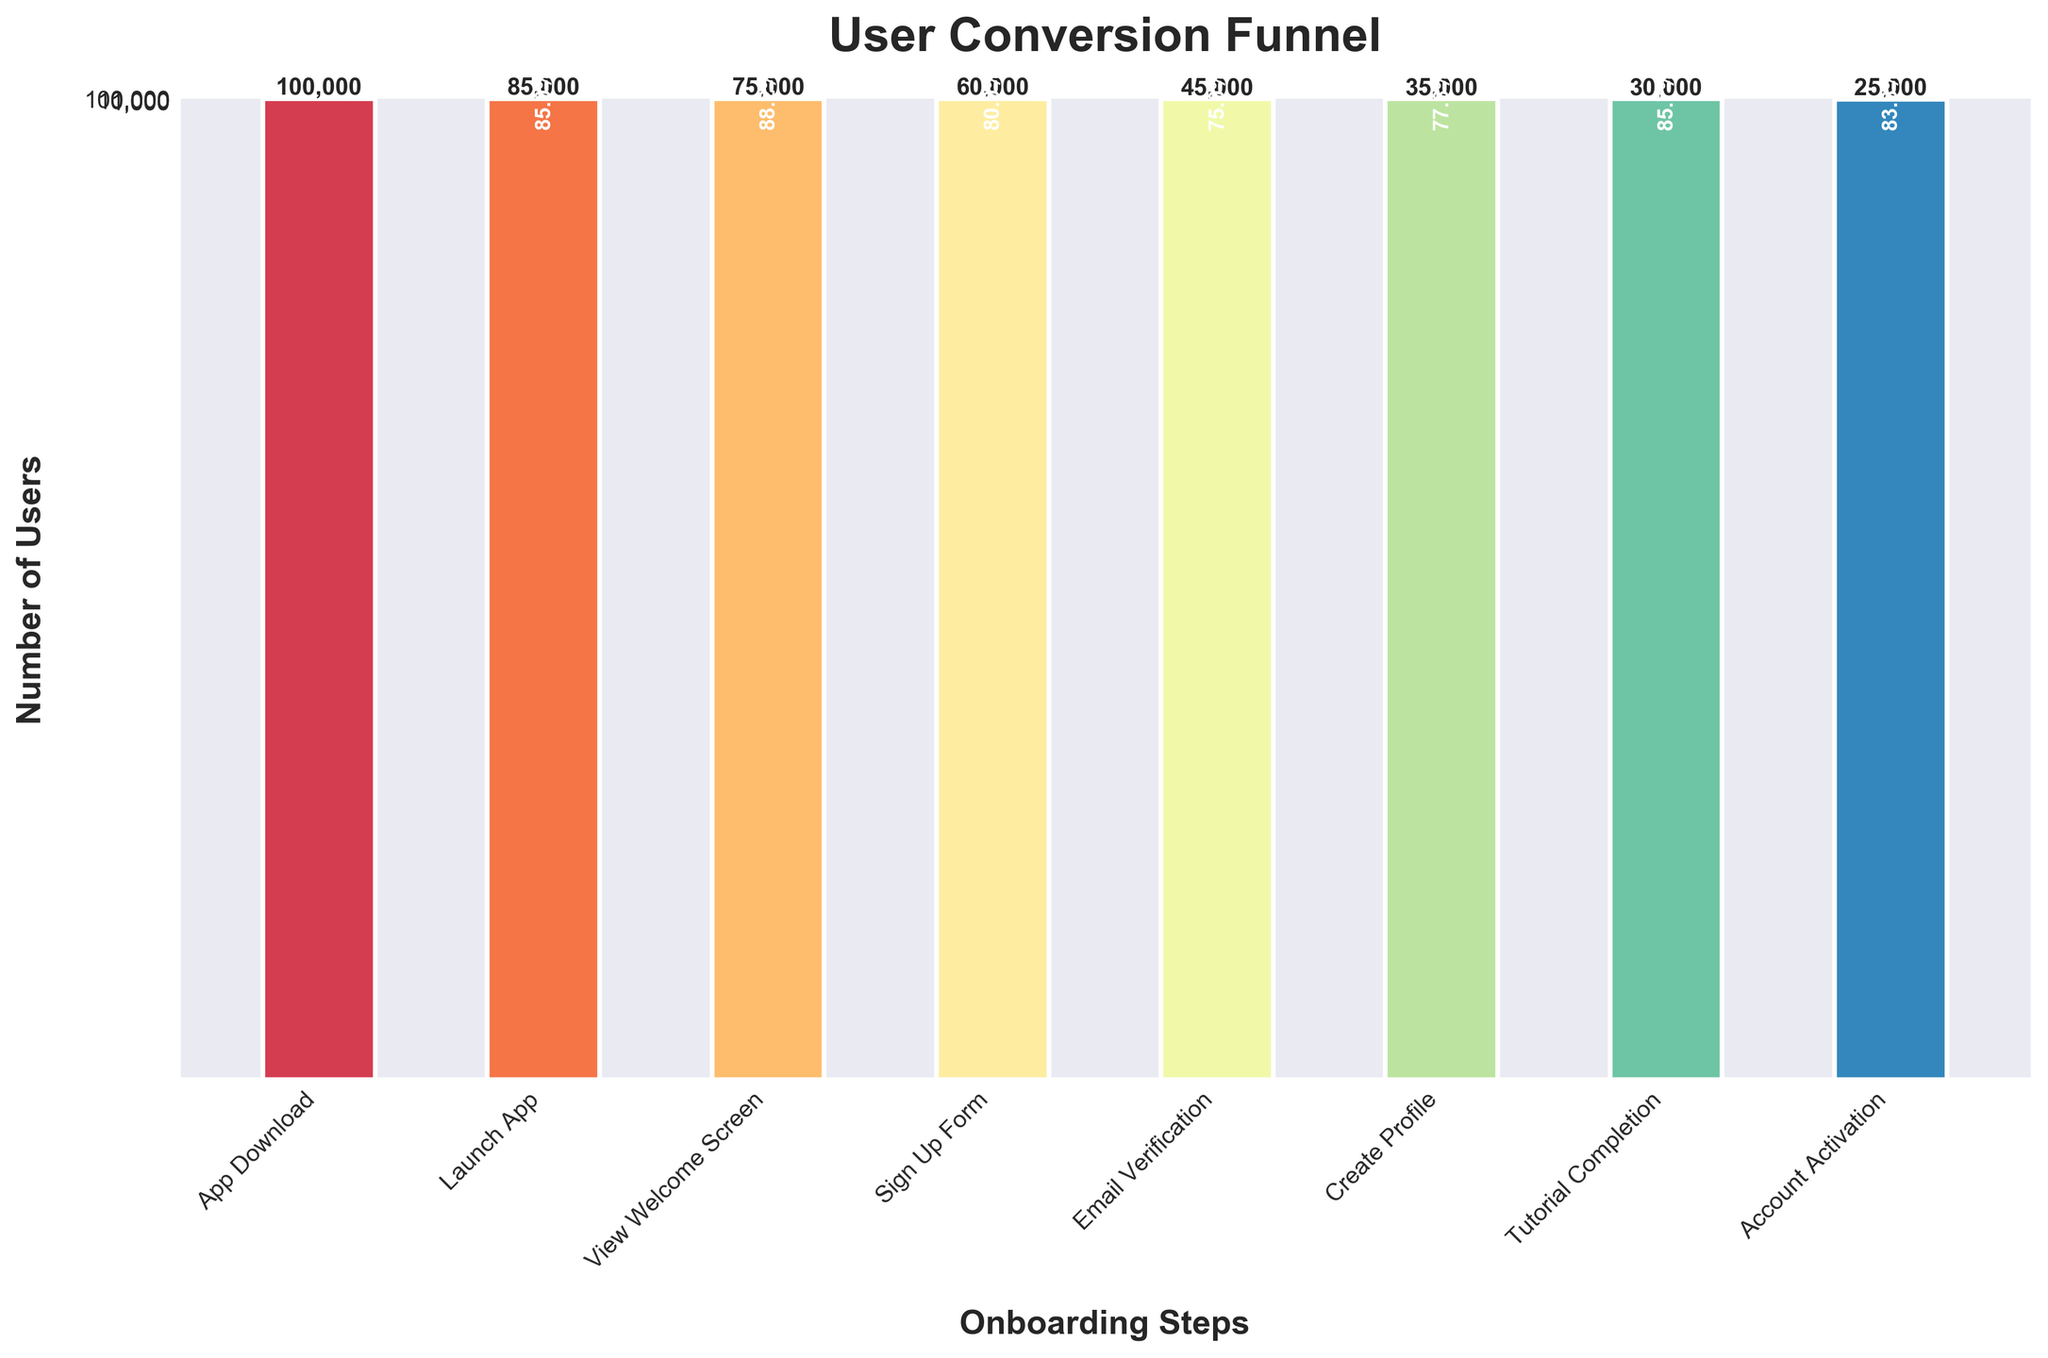What is the title of the funnel chart? The title of a chart is typically displayed at the top. It describes the content of the chart. In this case, the title 'User Conversion Funnel' is displayed at the top, making it clear that the chart illustrates user conversion steps during an onboarding process.
Answer: User Conversion Funnel How many steps are there in the funnel chart? By counting the number of bars (categories) on the x-axis, we can see the total number of steps indicated in the chart.
Answer: 8 Which step has the highest number of users? The step with the highest bar on the y-axis represents the highest number of users. According to the data, the 'App Download' step has the highest number of users, as it is the starting point in the funnel.
Answer: App Download What is the difference in the number of users between the 'App Download' and 'Launch App' steps? To find the difference, subtract the number of users at the 'Launch App' step from the number of users at the 'App Download' step. This is calculated as 100,000 - 85,000.
Answer: 15,000 How many users have completed all steps from 'App Download' to 'Account Activation'? The number of users who have completed all steps is represented by the value of the final step, 'Account Activation', at the bottom of the funnel.
Answer: 25,000 Which step has more users: 'Sign Up Form' or 'Email Verification'? By comparing the heights of the bars representing 'Sign Up Form' and 'Email Verification', we see that 'Sign Up Form' (60,000 users) is higher than 'Email Verification' (45,000 users).
Answer: Sign Up Form Does the step 'Create Profile' have more or fewer users than the 'View Welcome Screen' step? The bar for 'Create Profile' (35,000 users) is shorter than the bar for 'View Welcome Screen' (75,000 users), indicating fewer users.
Answer: Fewer What is the conversion rate from 'Launch App' to 'View Welcome Screen'? To calculate the conversion rate, divide the number of users who viewed the welcome screen by the number of users who launched the app, and then multiply by 100 to get a percentage. This is (75,000 / 85,000) * 100. 75,000 divided by 85,000 equals approximately 0.882, and multiplied by 100 gives approximately 88.2%.
Answer: 88.2% What is the lowest conversion rate between any two consecutive steps? By computing the conversion rate between each consecutive step and comparing them, we find the smallest percentage. Conversions: 'App Download' to 'Launch App' (85%), 'Launch App' to 'View Welcome Screen' (88.2%), 'View Welcome Screen' to 'Sign Up Form' (80%), 'Sign Up Form' to 'Email Verification' (75%), 'Email Verification' to 'Create Profile' (77.8%), 'Create Profile' to 'Tutorial Completion' (85.7%), 'Tutorial Completion' to 'Account Activation' (83.3%). The lowest conversion rate is 75% from 'Sign Up Form' to 'Email Verification'.
Answer: 75% Between which steps do we see the highest drop in the number of users? To identify the highest drop, we look for the largest difference between consecutive steps. The highest drop is from 'Sign Up Form' (60,000 users) to 'Email Verification' (45,000 users). The difference is 15,000 users.
Answer: Sign Up Form to Email Verification 